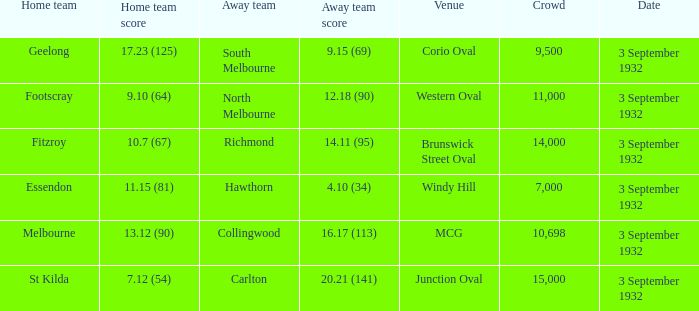What date is listed for the team that has an Away team score of 20.21 (141)? 3 September 1932. 